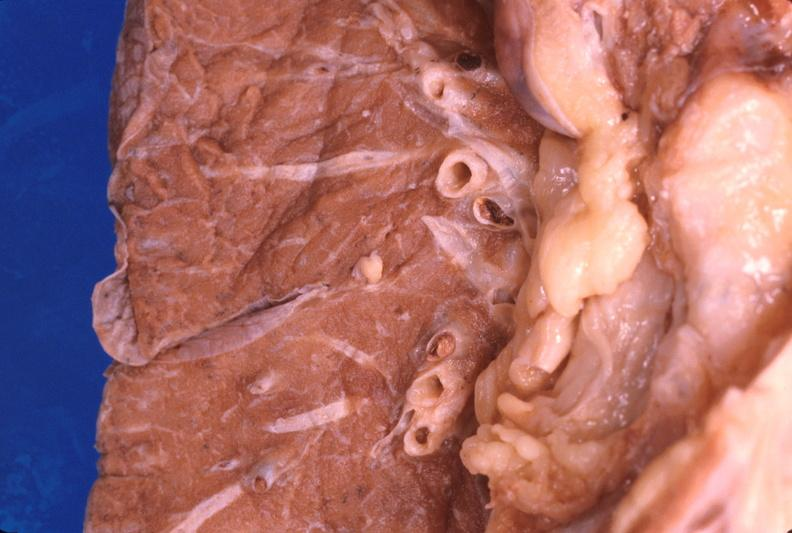what does this image show?
Answer the question using a single word or phrase. Thromboembolus from leg veins in pulmonary artery 